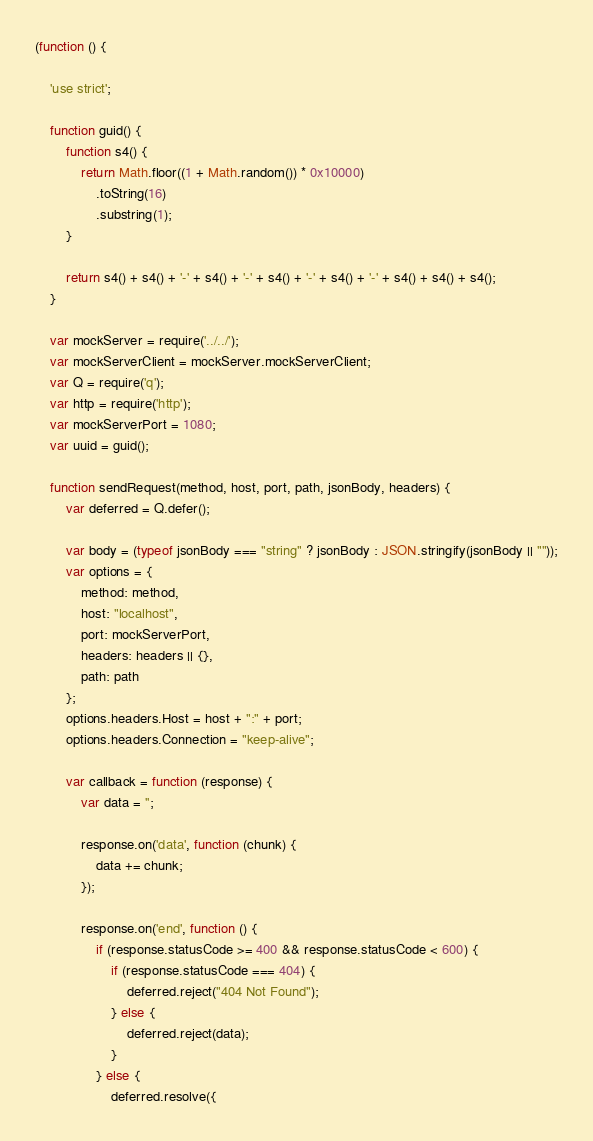Convert code to text. <code><loc_0><loc_0><loc_500><loc_500><_JavaScript_>(function () {

    'use strict';

    function guid() {
        function s4() {
            return Math.floor((1 + Math.random()) * 0x10000)
                .toString(16)
                .substring(1);
        }

        return s4() + s4() + '-' + s4() + '-' + s4() + '-' + s4() + '-' + s4() + s4() + s4();
    }

    var mockServer = require('../../');
    var mockServerClient = mockServer.mockServerClient;
    var Q = require('q');
    var http = require('http');
    var mockServerPort = 1080;
    var uuid = guid();

    function sendRequest(method, host, port, path, jsonBody, headers) {
        var deferred = Q.defer();

        var body = (typeof jsonBody === "string" ? jsonBody : JSON.stringify(jsonBody || ""));
        var options = {
            method: method,
            host: "localhost",
            port: mockServerPort,
            headers: headers || {},
            path: path
        };
        options.headers.Host = host + ":" + port;
        options.headers.Connection = "keep-alive";

        var callback = function (response) {
            var data = '';

            response.on('data', function (chunk) {
                data += chunk;
            });

            response.on('end', function () {
                if (response.statusCode >= 400 && response.statusCode < 600) {
                    if (response.statusCode === 404) {
                        deferred.reject("404 Not Found");
                    } else {
                        deferred.reject(data);
                    }
                } else {
                    deferred.resolve({</code> 